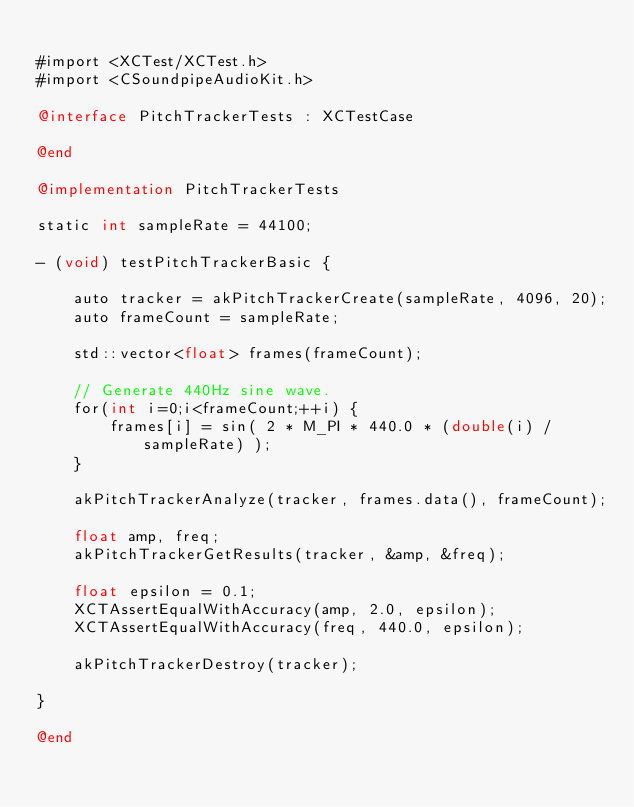<code> <loc_0><loc_0><loc_500><loc_500><_ObjectiveC_>
#import <XCTest/XCTest.h>
#import <CSoundpipeAudioKit.h>

@interface PitchTrackerTests : XCTestCase

@end

@implementation PitchTrackerTests

static int sampleRate = 44100;

- (void) testPitchTrackerBasic {

    auto tracker = akPitchTrackerCreate(sampleRate, 4096, 20);
    auto frameCount = sampleRate;

    std::vector<float> frames(frameCount);

    // Generate 440Hz sine wave.
    for(int i=0;i<frameCount;++i) {
        frames[i] = sin( 2 * M_PI * 440.0 * (double(i) / sampleRate) );
    }

    akPitchTrackerAnalyze(tracker, frames.data(), frameCount);

    float amp, freq;
    akPitchTrackerGetResults(tracker, &amp, &freq);

    float epsilon = 0.1;
    XCTAssertEqualWithAccuracy(amp, 2.0, epsilon);
    XCTAssertEqualWithAccuracy(freq, 440.0, epsilon);

    akPitchTrackerDestroy(tracker);

}

@end
</code> 